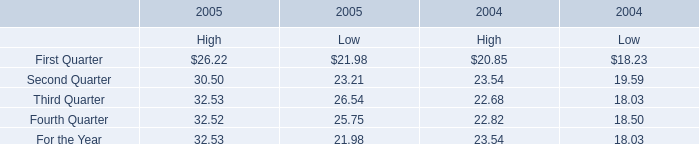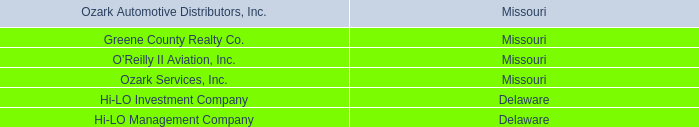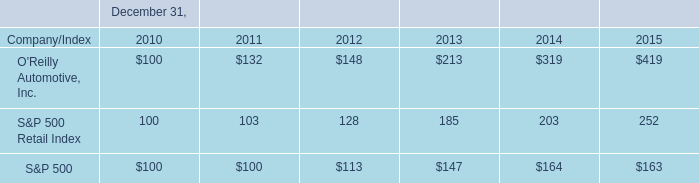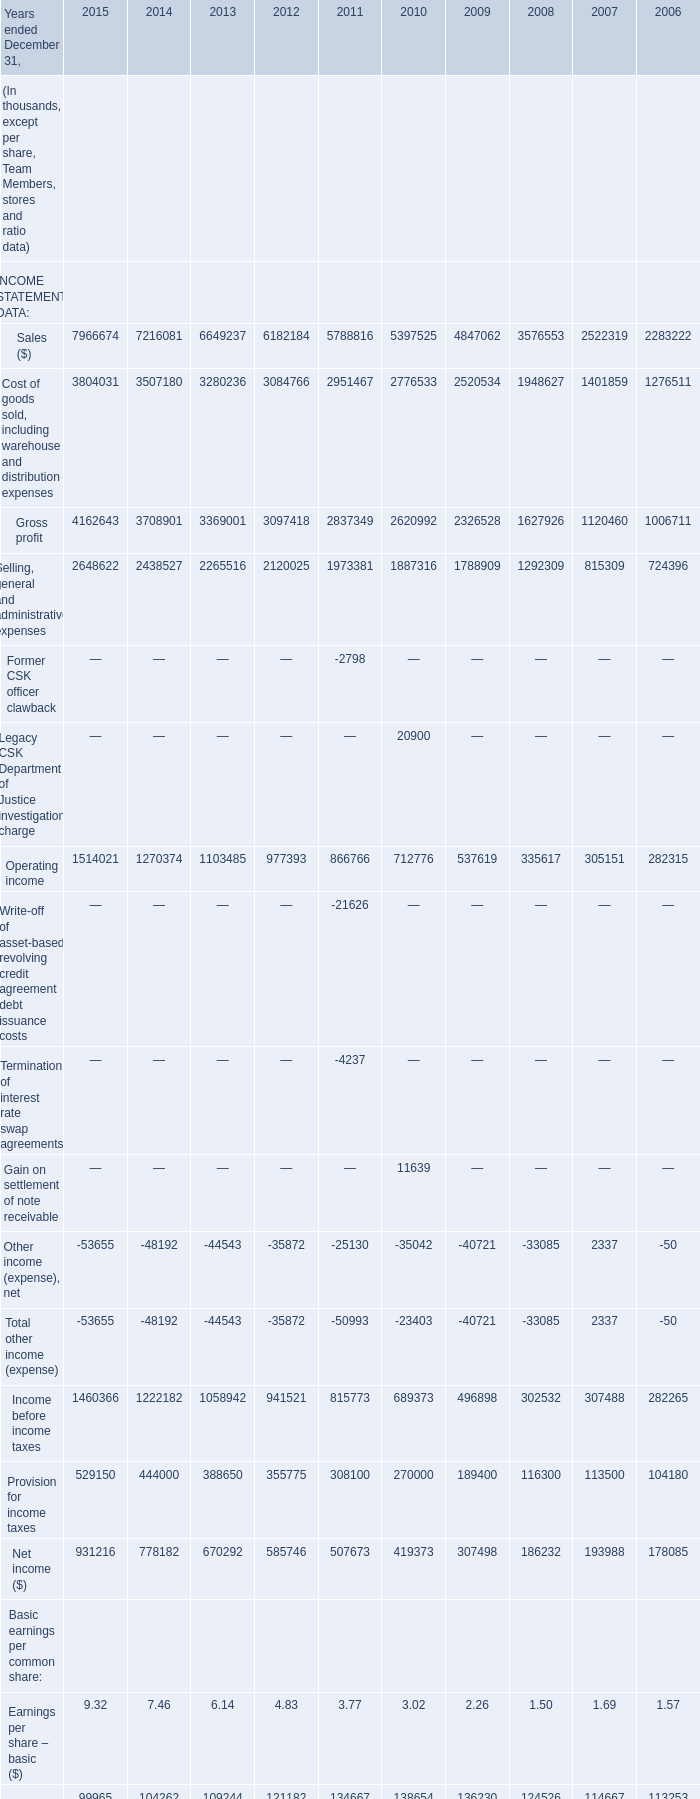what is the roi of an investment in the s&p500 from 2010 to 2011? 
Computations: ((100 - 100) / 100)
Answer: 0.0. 